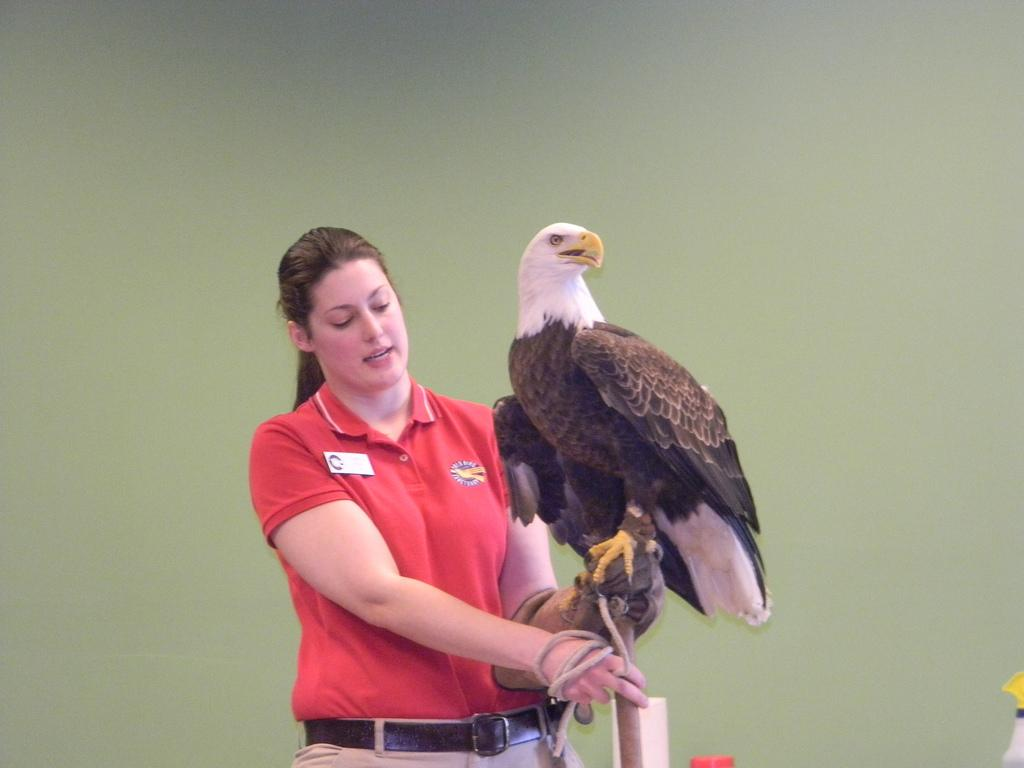Who is the main subject in the image? There is a woman in the image. What is the woman wearing? The woman is wearing a red T-shirt. What animal is in front of the woman? There is an eagle in front of the woman. What type of stick can be seen on the ground near the woman? There is no stick present in the image. 